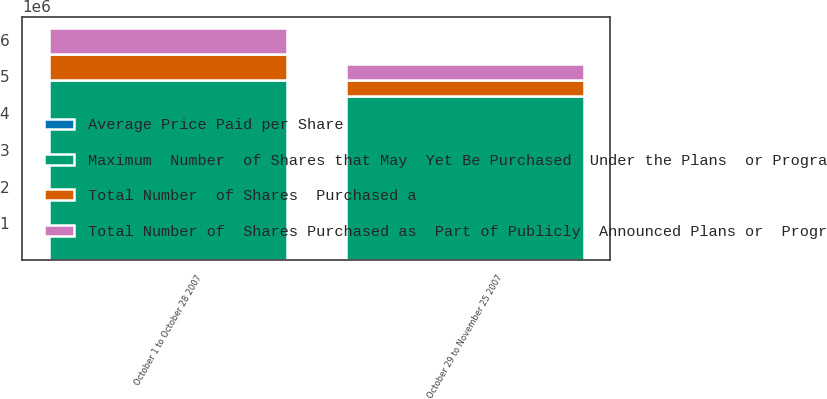Convert chart. <chart><loc_0><loc_0><loc_500><loc_500><stacked_bar_chart><ecel><fcel>October 1 to October 28 2007<fcel>October 29 to November 25 2007<nl><fcel>Total Number  of Shares  Purchased a<fcel>705292<fcel>431170<nl><fcel>Average Price Paid per Share<fcel>53.53<fcel>48.11<nl><fcel>Total Number of  Shares Purchased as  Part of Publicly  Announced Plans or  Programs<fcel>705292<fcel>431170<nl><fcel>Maximum  Number  of Shares that May  Yet Be Purchased  Under the Plans  or Programs b<fcel>4.90482e+06<fcel>4.47365e+06<nl></chart> 